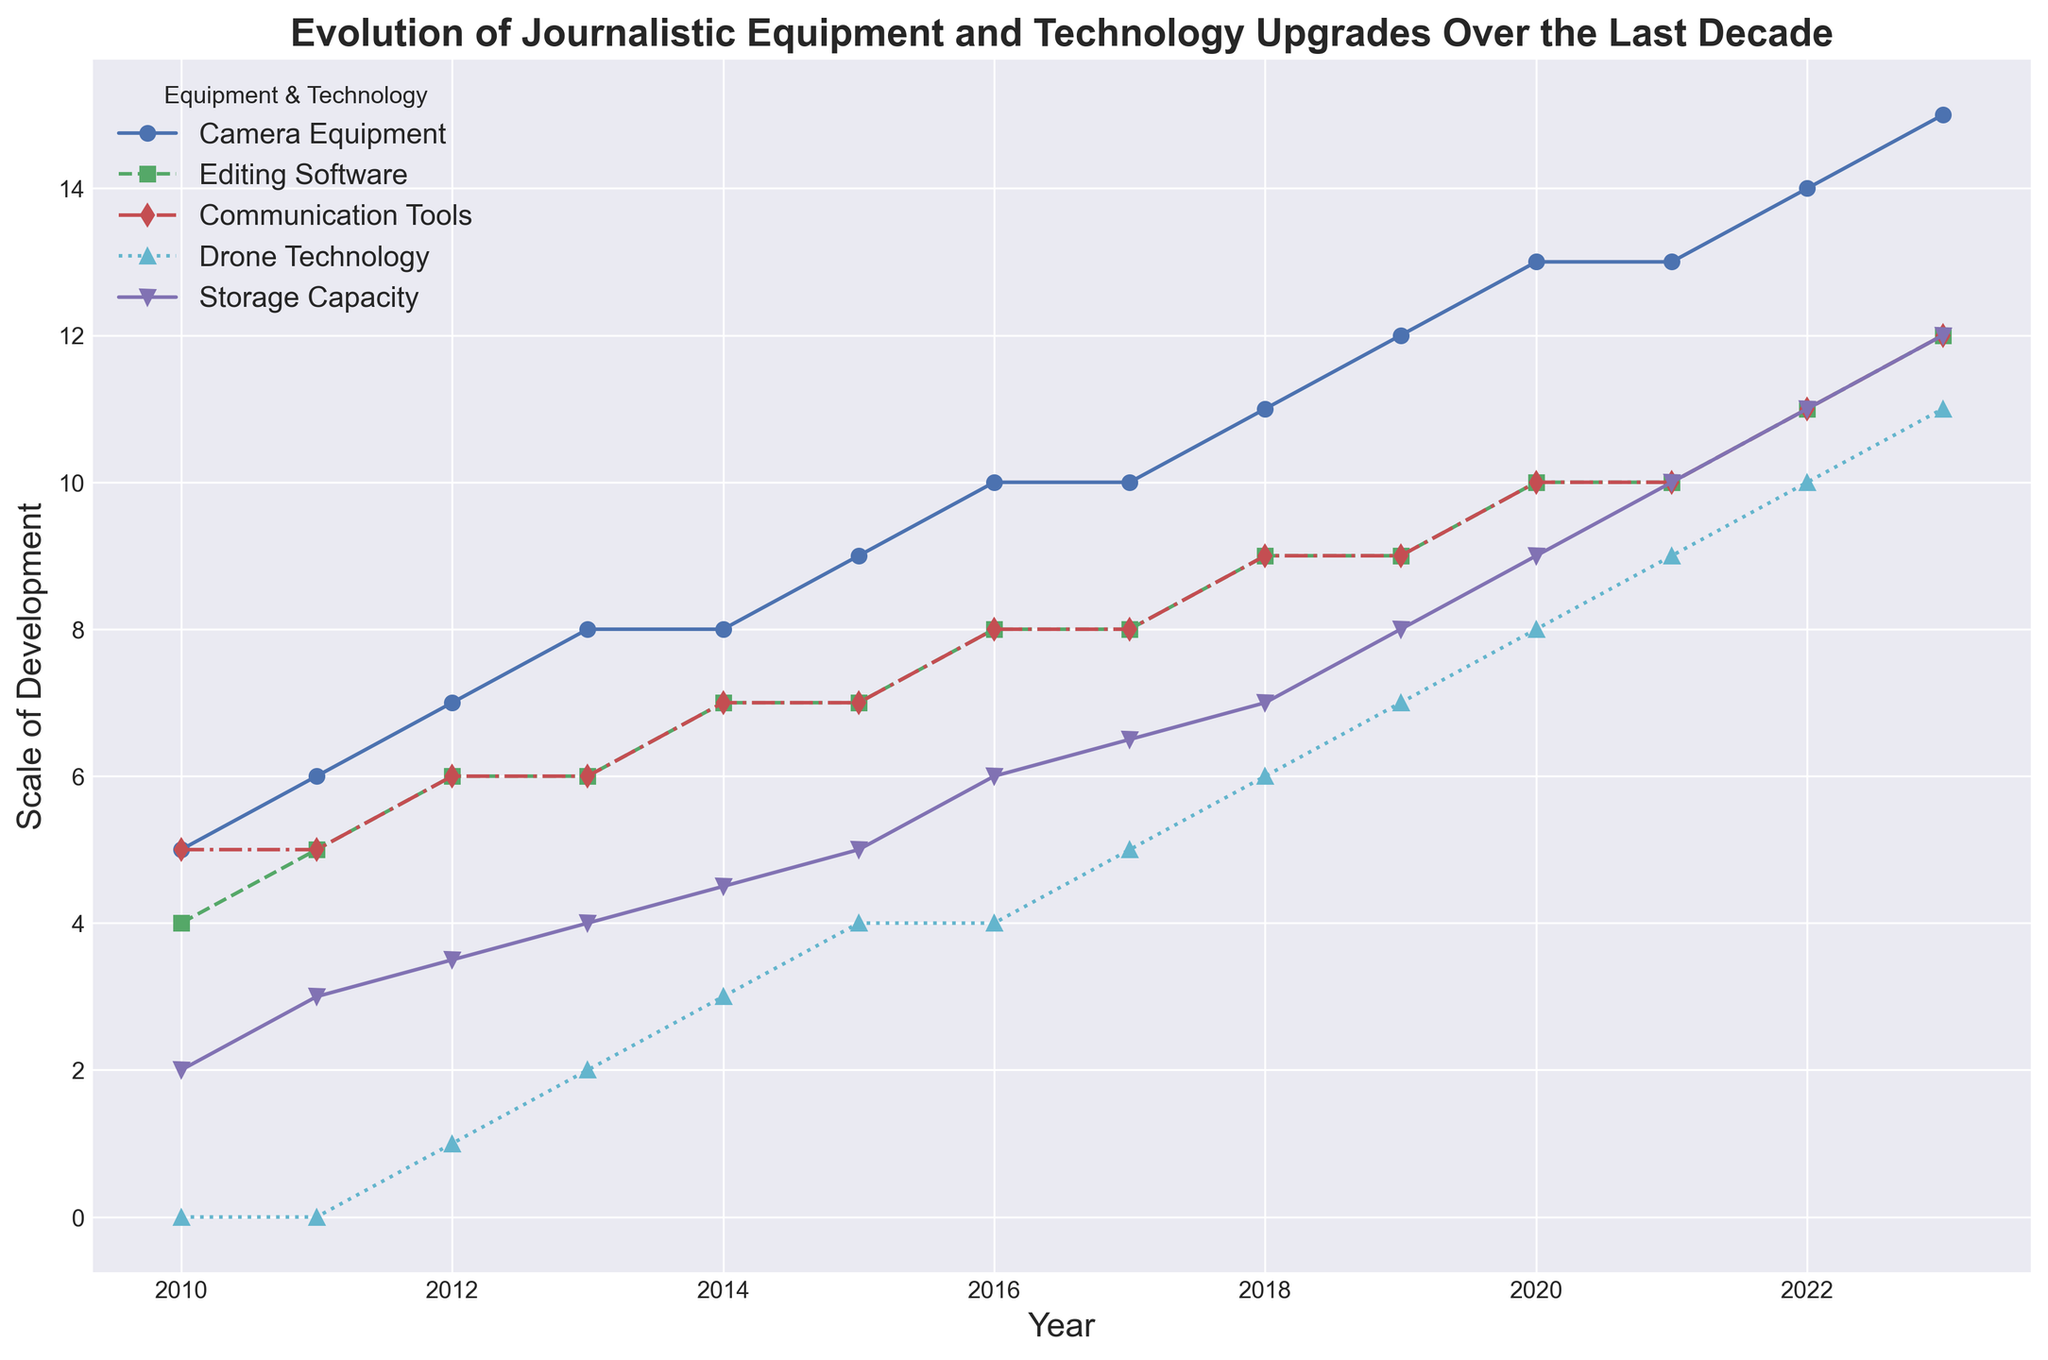How has camera equipment changed over the last decade? The plot shows an increase in the scale of camera equipment development from 5 in 2010 to 15 in 2023. By looking at the blue line, one can observe a consistent upward trend in camera technology over these years.
Answer: Increased from 5 to 15 In which year did drone technology first appear on the chart, and how did it evolve in its first five years? Drone Technology first appears in 2012 with a scale of 1. By examining the cyan line, from 2012 to 2016, Drone Technology increased from 1 to 4.
Answer: 2012, increased from 1 to 4 What is the difference in scale between the highest and lowest developed technology in 2023? In 2023, Camera Equipment has the highest scale with a value of 15, and Communication Tools and Editing Software have the lowest scale with a value of 12. The difference is 15 - 12 which equals 3.
Answer: 3 Which technology showed the steepest increase between 2018 and 2023, and by how much did it increase? By comparing the slopes of the different lines, Camera Equipment showed the steepest increase, going from 11 in 2018 to 15 in 2023, an increase of 4.
Answer: Camera Equipment, increased by 4 In which year did Editing Software and Communication Tools become identical in scale, and what was their value? The green and red lines intersect at the year 2011, where both Editing Software and Communication Tools have a scale of 5.
Answer: 2011, value of 5 How does the growth pattern of Storage Capacity compare with that of Communication Tools from 2010 to 2023? Storage Capacity shows a consistent upward trend starting at 2 and reaching 12 by 2023 (purple line). Communication Tools (red line) also show an upward trend but at a slower rate, starting at 5 in 2010 and ending at 12 in 2023. Both end at the same scale but grew at different paces.
Answer: Storage Capacity grew faster initially, but both reached 12 by 2023 Between which consecutive years did Camera Equipment see the largest jump, and what was the value of the jump? The largest jump for camera equipment is observed between 2019 and 2020, where the blue line goes from 12 to 13, indicating a jump of 1.
Answer: Between 2019 and 2020, jump of 1 